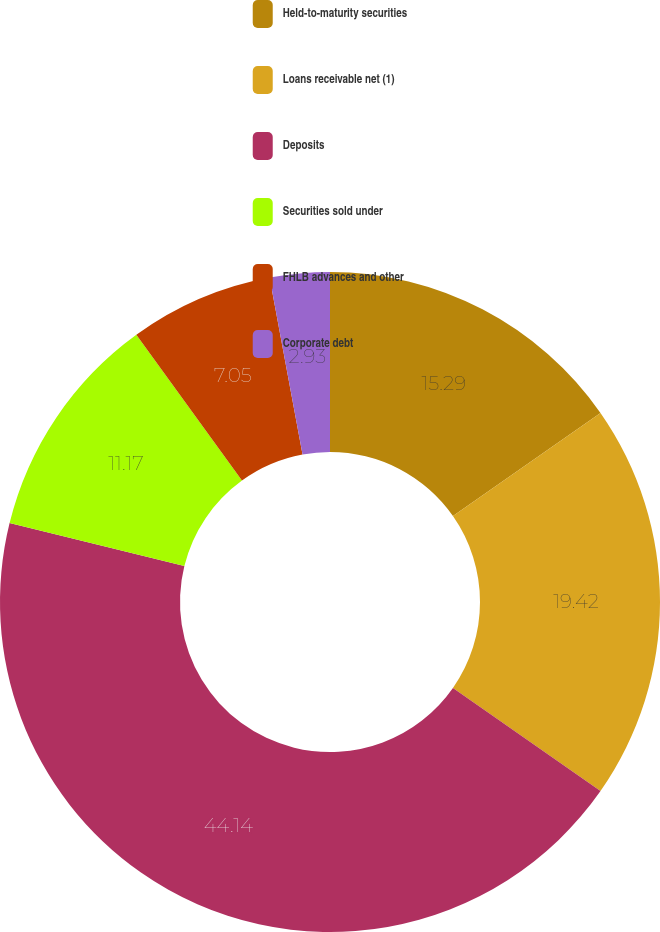Convert chart. <chart><loc_0><loc_0><loc_500><loc_500><pie_chart><fcel>Held-to-maturity securities<fcel>Loans receivable net (1)<fcel>Deposits<fcel>Securities sold under<fcel>FHLB advances and other<fcel>Corporate debt<nl><fcel>15.29%<fcel>19.41%<fcel>44.13%<fcel>11.17%<fcel>7.05%<fcel>2.93%<nl></chart> 